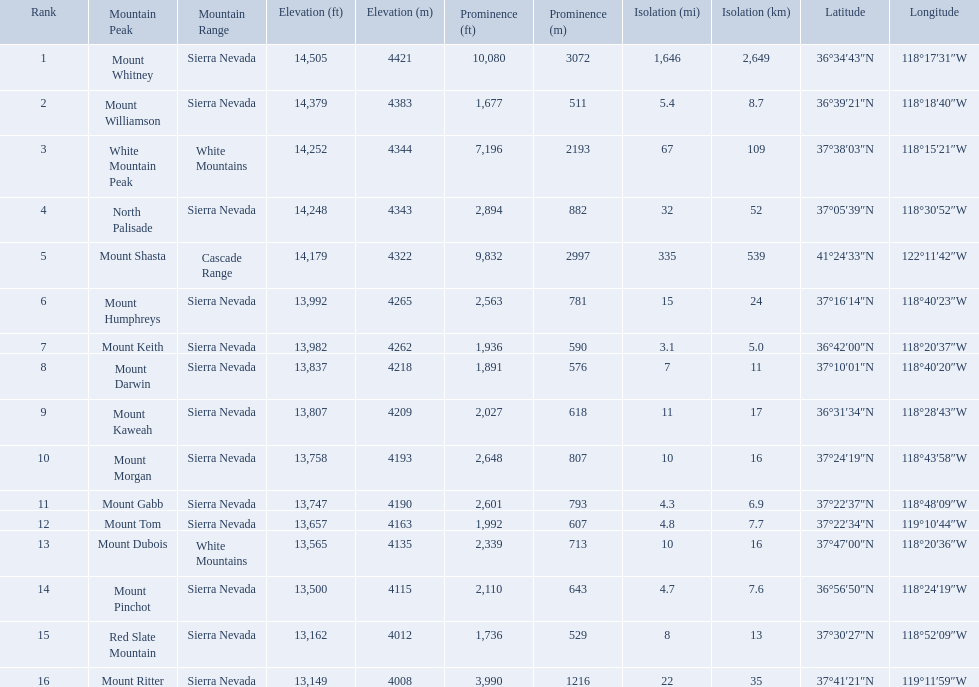What are all of the mountain peaks? Mount Whitney, Mount Williamson, White Mountain Peak, North Palisade, Mount Shasta, Mount Humphreys, Mount Keith, Mount Darwin, Mount Kaweah, Mount Morgan, Mount Gabb, Mount Tom, Mount Dubois, Mount Pinchot, Red Slate Mountain, Mount Ritter. In what ranges are they? Sierra Nevada, Sierra Nevada, White Mountains, Sierra Nevada, Cascade Range, Sierra Nevada, Sierra Nevada, Sierra Nevada, Sierra Nevada, Sierra Nevada, Sierra Nevada, Sierra Nevada, White Mountains, Sierra Nevada, Sierra Nevada, Sierra Nevada. Which peak is in the cascade range? Mount Shasta. Which mountain peaks have a prominence over 9,000 ft? Mount Whitney, Mount Shasta. Of those, which one has the the highest prominence? Mount Whitney. What are the mountain peaks? Mount Whitney, Mount Williamson, White Mountain Peak, North Palisade, Mount Shasta, Mount Humphreys, Mount Keith, Mount Darwin, Mount Kaweah, Mount Morgan, Mount Gabb, Mount Tom, Mount Dubois, Mount Pinchot, Red Slate Mountain, Mount Ritter. Of these, which one has a prominence more than 10,000 ft? Mount Whitney. What are the heights of the californian mountain peaks? 14,505 ft\n4421 m, 14,379 ft\n4383 m, 14,252 ft\n4344 m, 14,248 ft\n4343 m, 14,179 ft\n4322 m, 13,992 ft\n4265 m, 13,982 ft\n4262 m, 13,837 ft\n4218 m, 13,807 ft\n4209 m, 13,758 ft\n4193 m, 13,747 ft\n4190 m, 13,657 ft\n4163 m, 13,565 ft\n4135 m, 13,500 ft\n4115 m, 13,162 ft\n4012 m, 13,149 ft\n4008 m. What elevation is 13,149 ft or less? 13,149 ft\n4008 m. What mountain peak is at this elevation? Mount Ritter. Which mountain peaks are lower than 14,000 ft? Mount Humphreys, Mount Keith, Mount Darwin, Mount Kaweah, Mount Morgan, Mount Gabb, Mount Tom, Mount Dubois, Mount Pinchot, Red Slate Mountain, Mount Ritter. Are any of them below 13,500? if so, which ones? Red Slate Mountain, Mount Ritter. What's the lowest peak? 13,149 ft\n4008 m. Which one is that? Mount Ritter. What mountain peak is listed for the sierra nevada mountain range? Mount Whitney. What mountain peak has an elevation of 14,379ft? Mount Williamson. Which mountain is listed for the cascade range? Mount Shasta. 